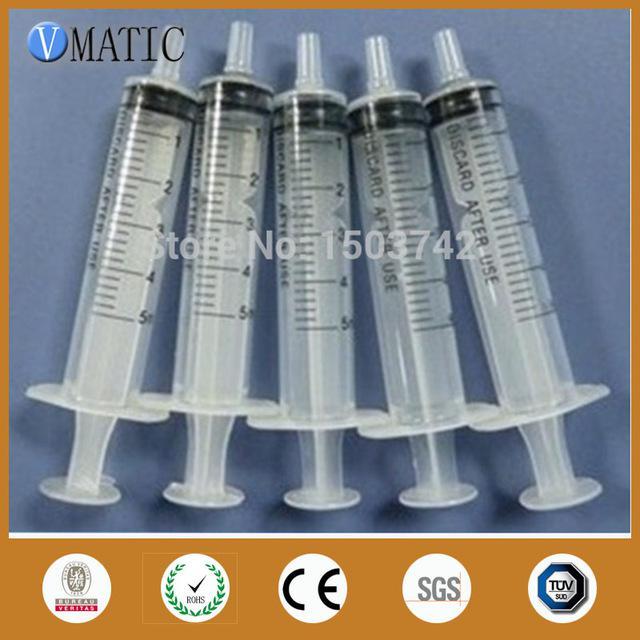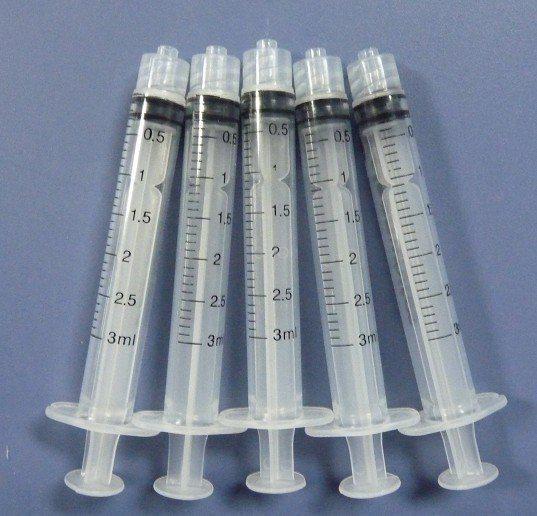The first image is the image on the left, the second image is the image on the right. Considering the images on both sides, is "The left and right image contains the same number of syringes." valid? Answer yes or no. Yes. 